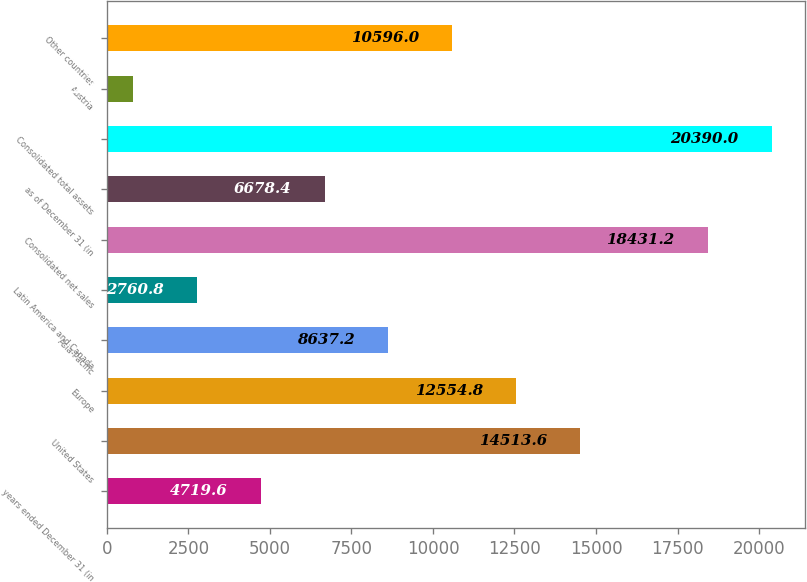<chart> <loc_0><loc_0><loc_500><loc_500><bar_chart><fcel>years ended December 31 (in<fcel>United States<fcel>Europe<fcel>Asia-Pacific<fcel>Latin America and Canada<fcel>Consolidated net sales<fcel>as of December 31 (in<fcel>Consolidated total assets<fcel>Austria<fcel>Other countries<nl><fcel>4719.6<fcel>14513.6<fcel>12554.8<fcel>8637.2<fcel>2760.8<fcel>18431.2<fcel>6678.4<fcel>20390<fcel>802<fcel>10596<nl></chart> 